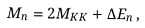<formula> <loc_0><loc_0><loc_500><loc_500>M _ { n } = 2 M _ { K K } + \Delta E _ { n } \, ,</formula> 